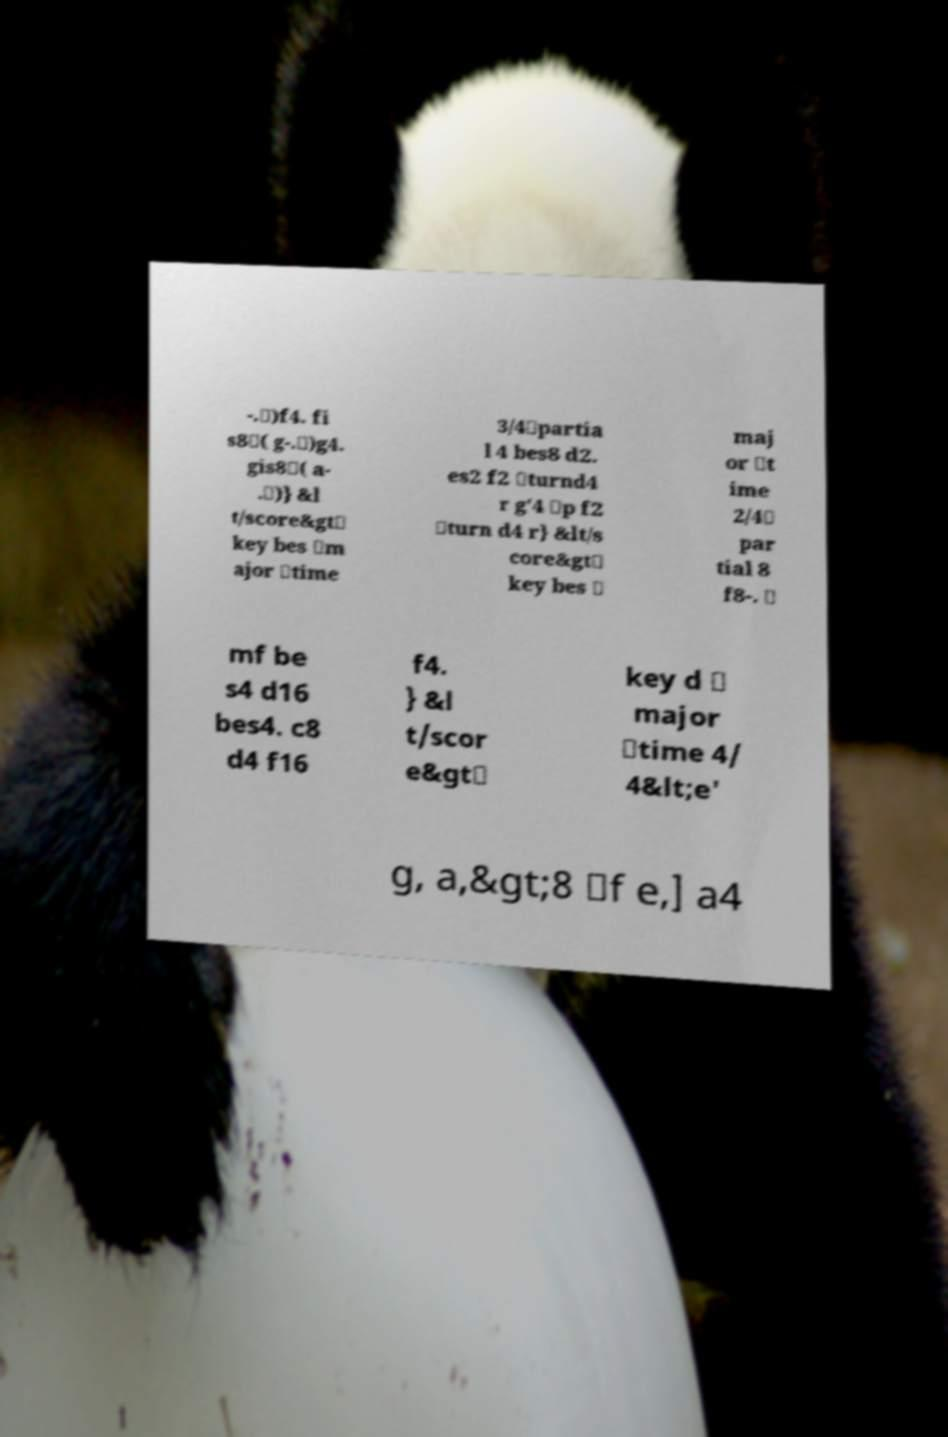Can you read and provide the text displayed in the image?This photo seems to have some interesting text. Can you extract and type it out for me? -.\)f4. fi s8\( g-.\)g4. gis8\( a- .\)} &l t/score&gt\ key bes \m ajor \time 3/4\partia l 4 bes8 d2. es2 f2 \turnd4 r g'4 \p f2 \turn d4 r} &lt/s core&gt\ key bes \ maj or \t ime 2/4\ par tial 8 f8-. \ mf be s4 d16 bes4. c8 d4 f16 f4. } &l t/scor e&gt\ key d \ major \time 4/ 4&lt;e' g, a,&gt;8 \f e,] a4 